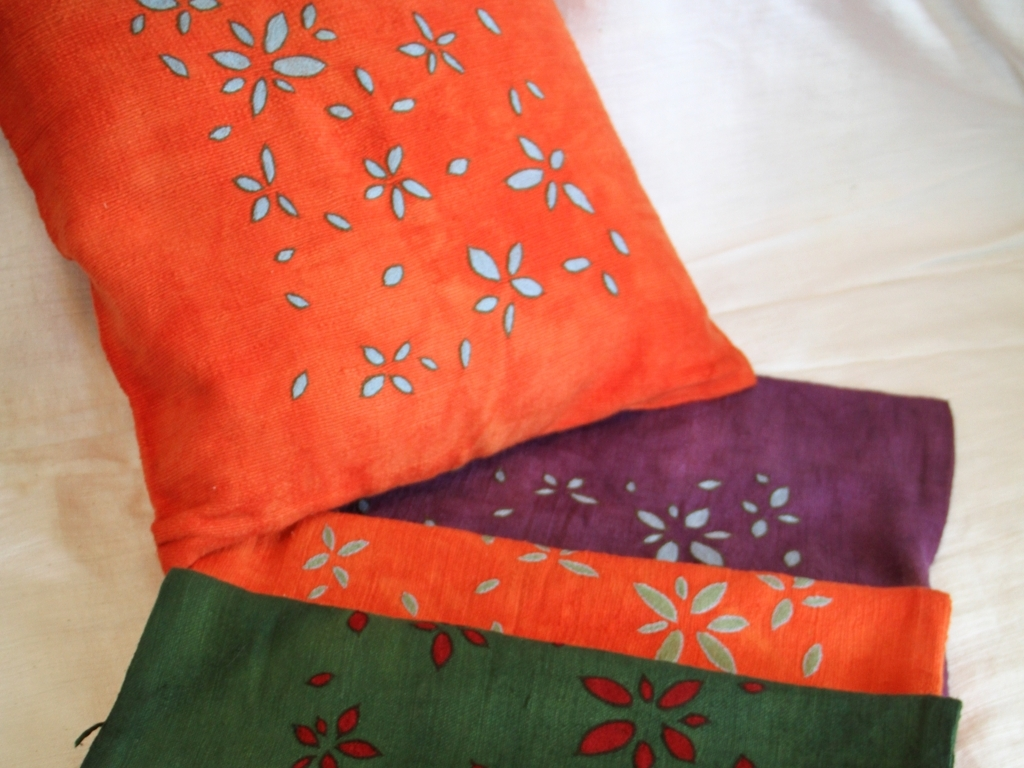What can you say about the colors in the image?
A. Rich
B. Dull
C. Faded
D. Washed-out The colors in the image are certainly vibrant and striking. Among the given choices, 'A. Rich' seems most fitting. The image showcases a stack of fabrics in bright and deep hues of orange, purple, and green, all with a complementary pattern that adds to the visual texture and richness. 